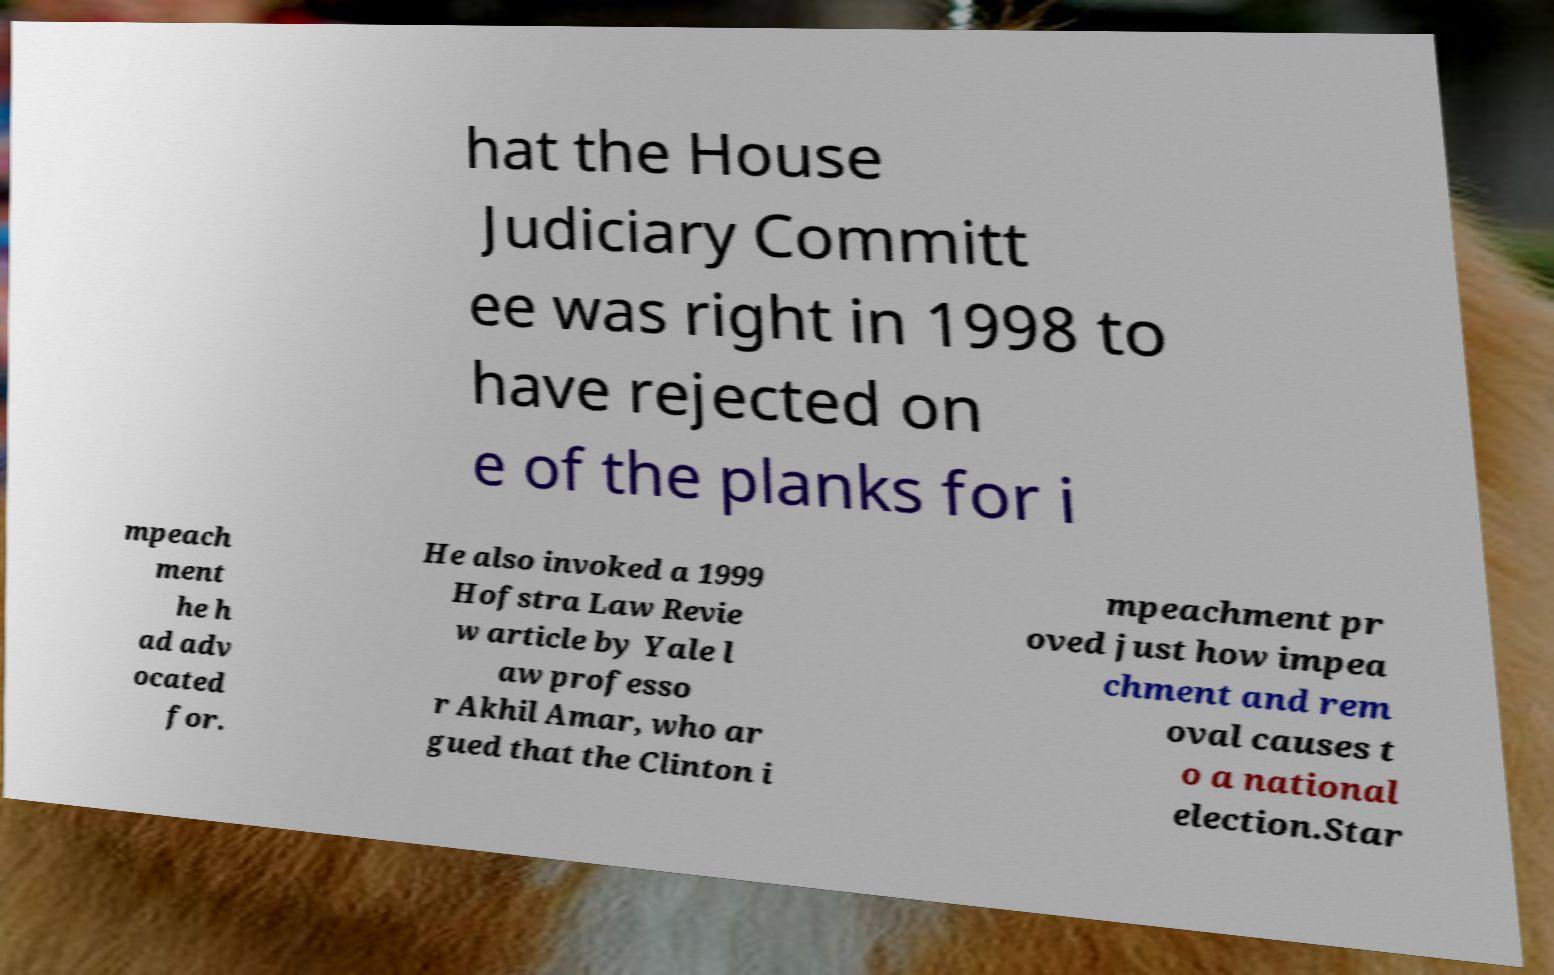For documentation purposes, I need the text within this image transcribed. Could you provide that? hat the House Judiciary Committ ee was right in 1998 to have rejected on e of the planks for i mpeach ment he h ad adv ocated for. He also invoked a 1999 Hofstra Law Revie w article by Yale l aw professo r Akhil Amar, who ar gued that the Clinton i mpeachment pr oved just how impea chment and rem oval causes t o a national election.Star 